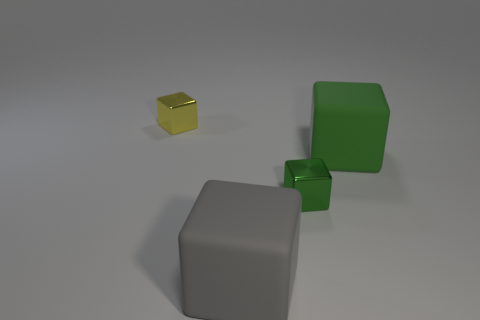The object that is both right of the large gray object and behind the small green metallic block has what shape?
Your answer should be very brief. Cube. Are there any large purple objects that have the same shape as the big gray thing?
Keep it short and to the point. No. How many objects are matte cubes behind the small green metal block or green rubber blocks?
Your answer should be compact. 1. Does the tiny block that is to the right of the tiny yellow metallic thing have the same color as the large object that is in front of the large green block?
Your answer should be compact. No. The yellow object is what size?
Provide a short and direct response. Small. How many small objects are green things or yellow objects?
Offer a terse response. 2. The other rubber object that is the same size as the gray matte object is what color?
Provide a succinct answer. Green. What number of other objects are the same shape as the big green thing?
Ensure brevity in your answer.  3. Is there another yellow block that has the same material as the small yellow cube?
Offer a very short reply. No. Is the material of the tiny thing that is to the right of the yellow shiny cube the same as the object on the left side of the gray matte thing?
Offer a very short reply. Yes. 